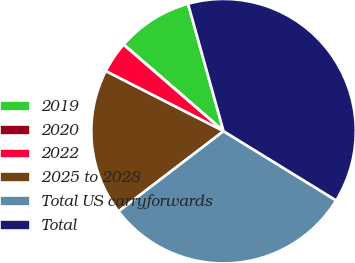Convert chart to OTSL. <chart><loc_0><loc_0><loc_500><loc_500><pie_chart><fcel>2019<fcel>2020<fcel>2022<fcel>2025 to 2028<fcel>Total US carryforwards<fcel>Total<nl><fcel>9.3%<fcel>0.03%<fcel>3.84%<fcel>17.89%<fcel>30.84%<fcel>38.1%<nl></chart> 